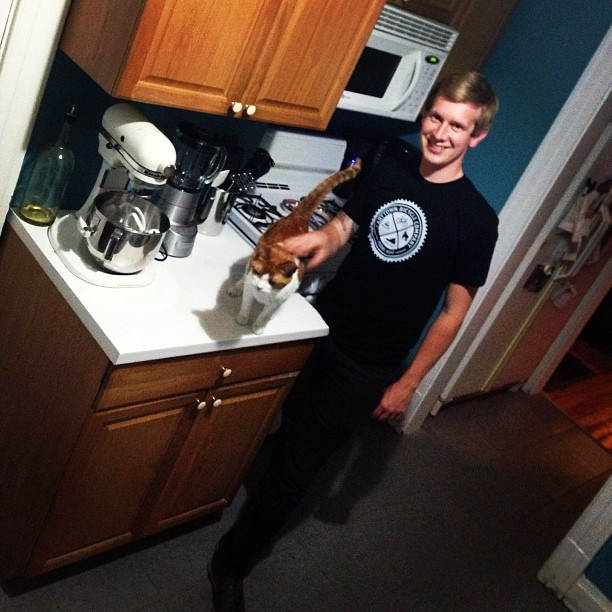Describe the objects in this image and their specific colors. I can see people in white, black, brown, maroon, and lightpink tones, refrigerator in white, maroon, black, and gray tones, oven in white, black, darkgray, and lightgray tones, microwave in white, darkgray, black, lightgray, and gray tones, and cat in white, maroon, darkgray, and gray tones in this image. 